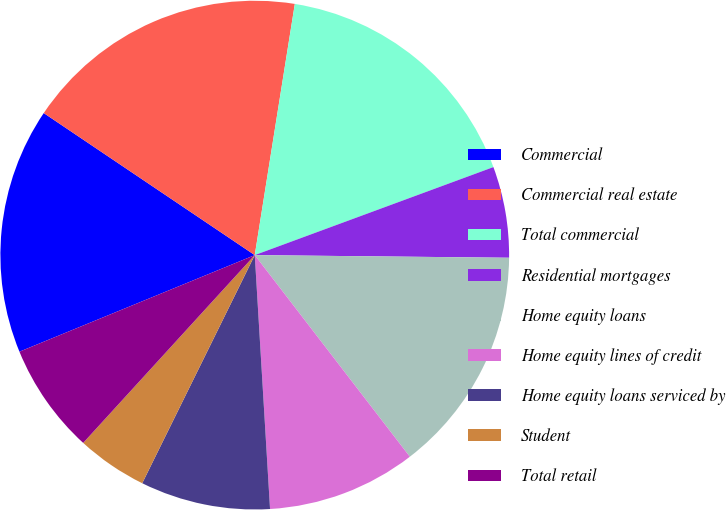Convert chart. <chart><loc_0><loc_0><loc_500><loc_500><pie_chart><fcel>Commercial<fcel>Commercial real estate<fcel>Total commercial<fcel>Residential mortgages<fcel>Home equity loans<fcel>Home equity lines of credit<fcel>Home equity loans serviced by<fcel>Student<fcel>Total retail<nl><fcel>15.63%<fcel>18.09%<fcel>16.86%<fcel>5.79%<fcel>14.4%<fcel>9.48%<fcel>8.25%<fcel>4.49%<fcel>7.02%<nl></chart> 